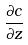<formula> <loc_0><loc_0><loc_500><loc_500>\frac { \partial c } { \partial z }</formula> 